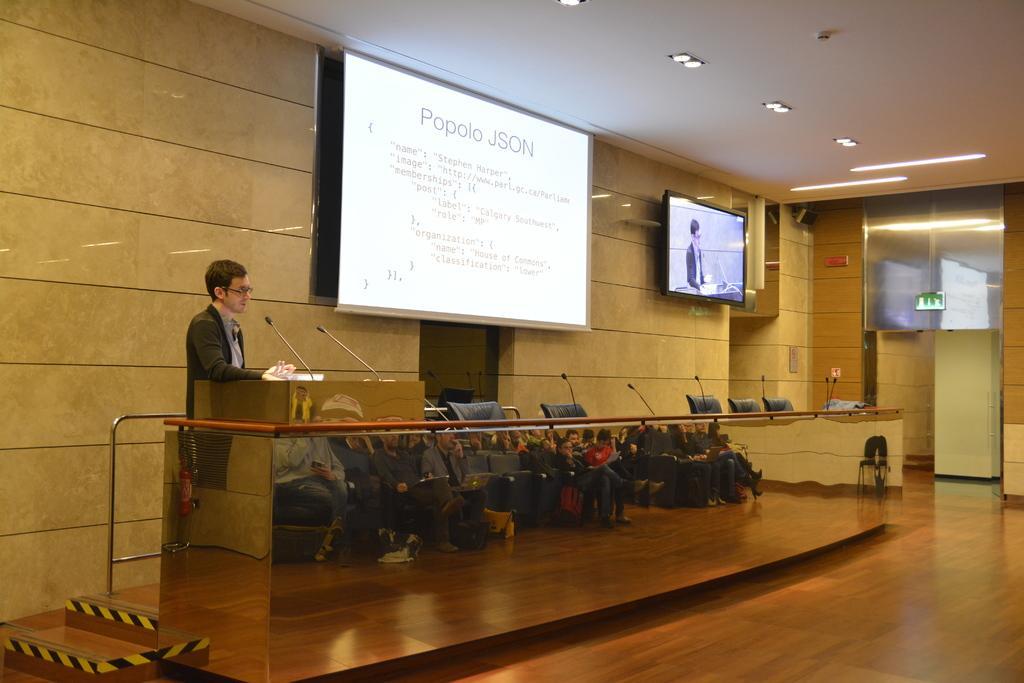How would you summarize this image in a sentence or two? In this image there is a person standing on the dais in front of the mic is delivering a speech, beside the person there are chairs and mic, behind the person there is a large projector and a television screen. 